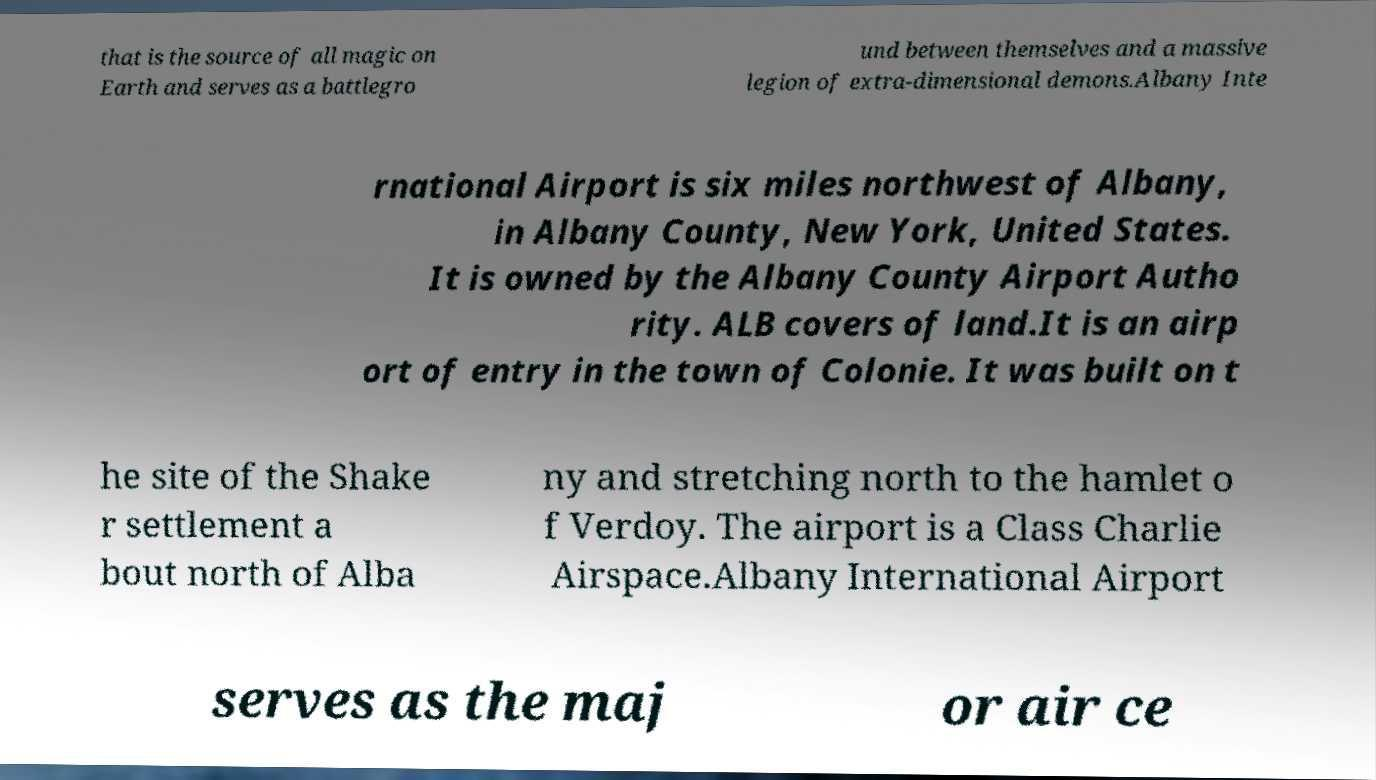Could you extract and type out the text from this image? that is the source of all magic on Earth and serves as a battlegro und between themselves and a massive legion of extra-dimensional demons.Albany Inte rnational Airport is six miles northwest of Albany, in Albany County, New York, United States. It is owned by the Albany County Airport Autho rity. ALB covers of land.It is an airp ort of entry in the town of Colonie. It was built on t he site of the Shake r settlement a bout north of Alba ny and stretching north to the hamlet o f Verdoy. The airport is a Class Charlie Airspace.Albany International Airport serves as the maj or air ce 